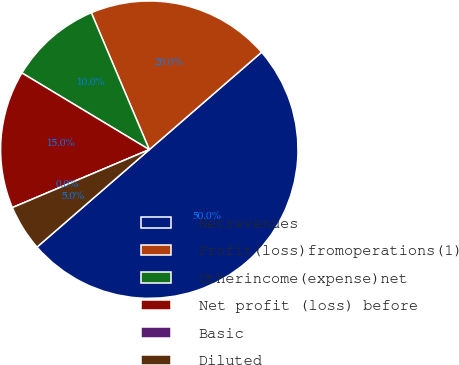<chart> <loc_0><loc_0><loc_500><loc_500><pie_chart><fcel>Netrevenues<fcel>Profit(loss)fromoperations(1)<fcel>Otherincome(expense)net<fcel>Net profit (loss) before<fcel>Basic<fcel>Diluted<nl><fcel>50.0%<fcel>20.0%<fcel>10.0%<fcel>15.0%<fcel>0.0%<fcel>5.0%<nl></chart> 